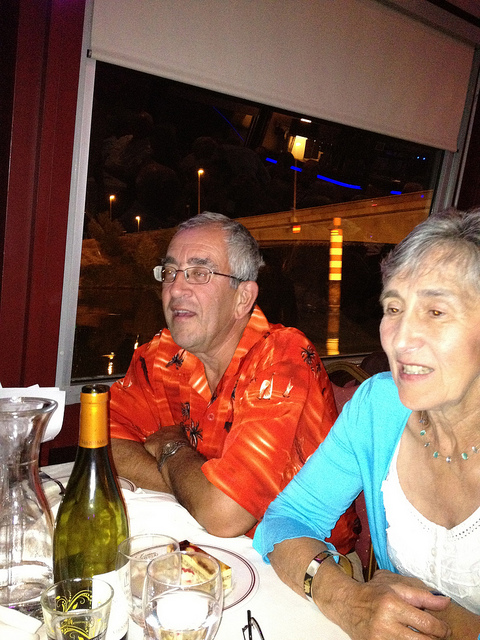Please provide the bounding box coordinate of the region this sentence describes: man. The bounding box coordinates for the region describing the man are approximately [0.29, 0.32, 0.66, 0.85]. 